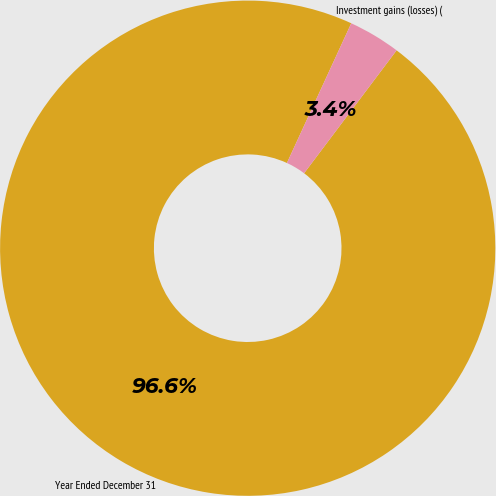<chart> <loc_0><loc_0><loc_500><loc_500><pie_chart><fcel>Year Ended December 31<fcel>Investment gains (losses) (<nl><fcel>96.6%<fcel>3.4%<nl></chart> 